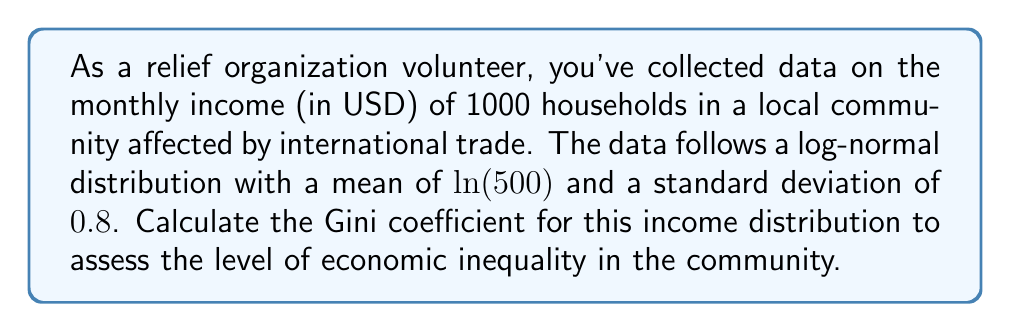Solve this math problem. To solve this problem, we'll follow these steps:

1) For a log-normal distribution, the Gini coefficient can be calculated using the formula:

   $$G = 2\Phi\left(\frac{\sigma}{\sqrt{2}}\right) - 1$$

   where $\Phi$ is the cumulative distribution function of the standard normal distribution, and $\sigma$ is the standard deviation of the logarithm of the variable.

2) We're given that $\sigma = 0.8$. Let's substitute this into the formula:

   $$G = 2\Phi\left(\frac{0.8}{\sqrt{2}}\right) - 1$$

3) Simplify inside the parentheses:

   $$G = 2\Phi(0.5656854249) - 1$$

4) Now we need to find $\Phi(0.5656854249)$. This is the area under the standard normal curve to the left of 0.5656854249. We can use a standard normal table or a calculator for this.

   $\Phi(0.5656854249) \approx 0.7142135624$

5) Substitute this value back into our equation:

   $$G = 2(0.7142135624) - 1$$

6) Simplify:

   $$G = 1.4284271248 - 1 = 0.4284271248$$

7) Round to four decimal places:

   $$G \approx 0.4284$$

This Gini coefficient of approximately 0.4284 indicates a moderate to high level of income inequality in the community. The Gini coefficient ranges from 0 (perfect equality) to 1 (perfect inequality), so a value of 0.4284 suggests that there is significant disparity in income distribution among the households in this community.
Answer: The Gini coefficient for the income distribution is approximately 0.4284, indicating moderate to high economic inequality in the community. 